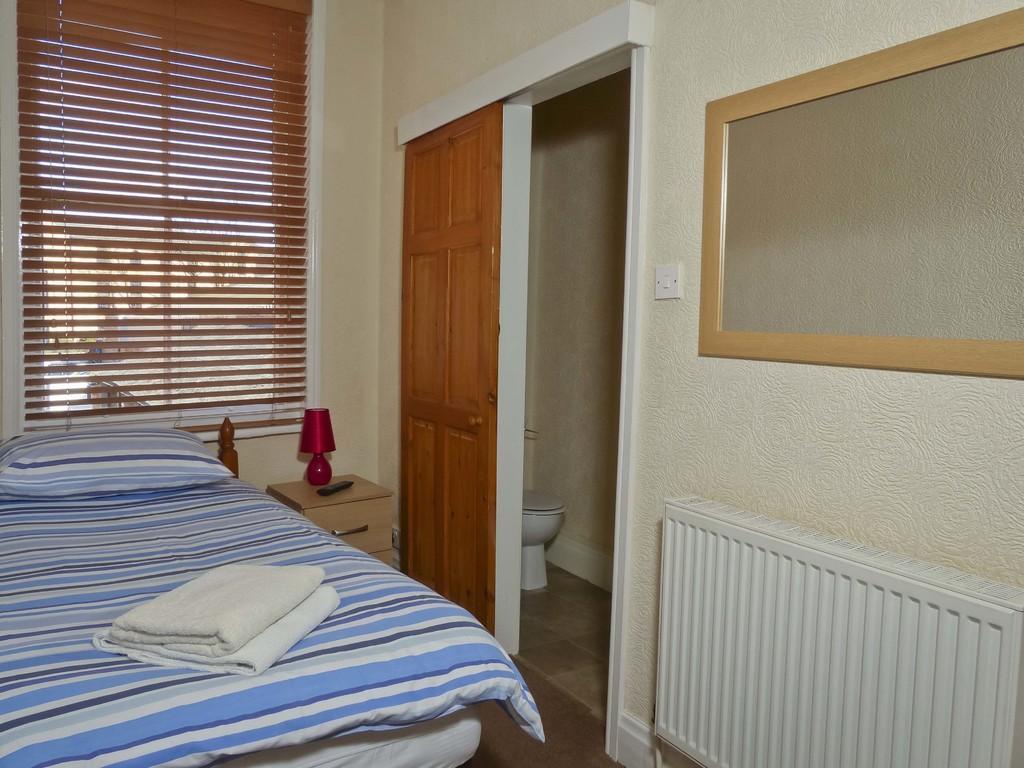Please provide a concise description of this image. This picture might be taken in a inside of the house, in this image in the center there is one bed. On the bed there are some blankets and pillow beside the bed there is one table, lamp, remote, door, toilet and on the right side there is a mirror on the wall. In the center there is a curtain and a window, at the bottom there is a floor. 